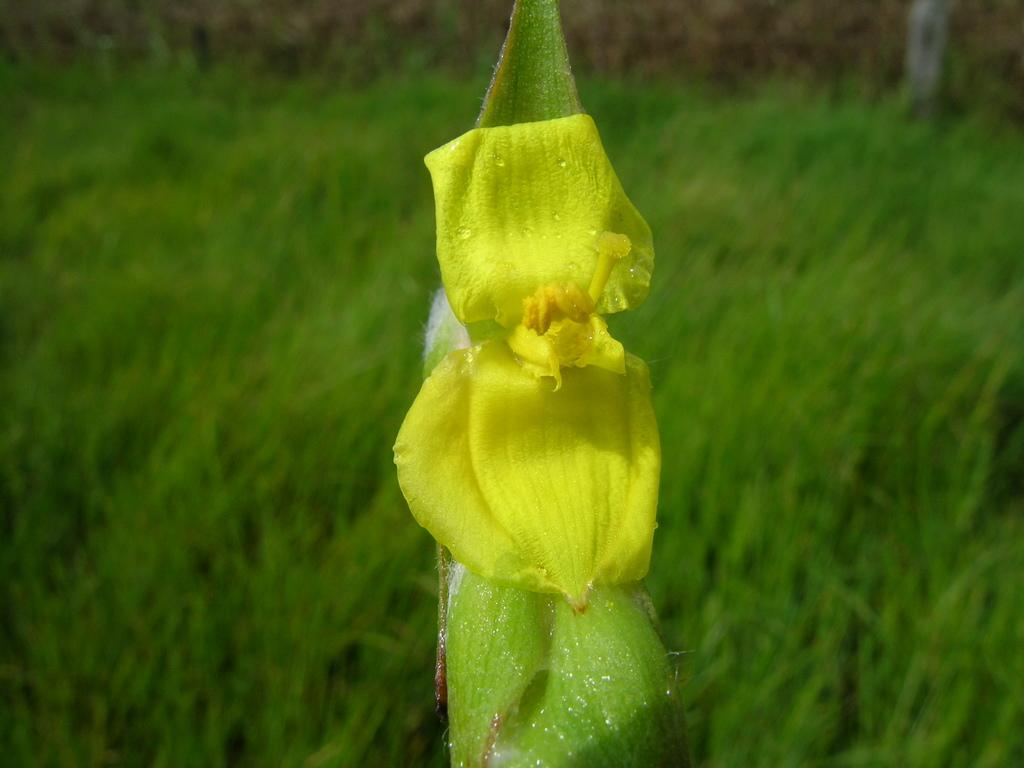What type of plant is featured in the image? There is a plant with a flower in the image. What is on the ground in the image? Grass is visible on the ground in the image. What color is the flower on the plant? The flower is yellow in color. What activity is the plant's manager participating in within the image? There is no manager or activity involving the plant in the image. 